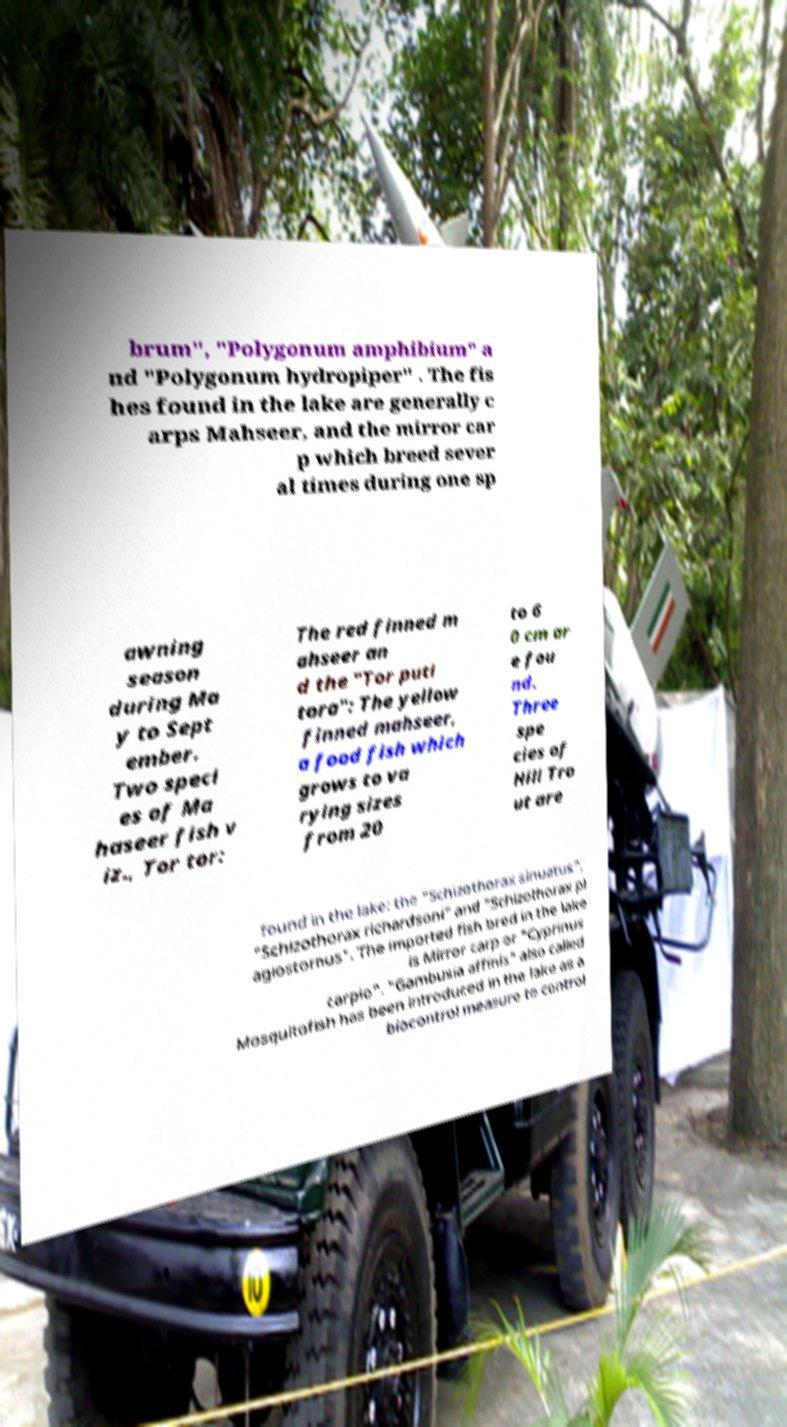Can you accurately transcribe the text from the provided image for me? brum", "Polygonum amphibium" a nd "Polygonum hydropiper" . The fis hes found in the lake are generally c arps Mahseer, and the mirror car p which breed sever al times during one sp awning season during Ma y to Sept ember. Two speci es of Ma haseer fish v iz., Tor tor: The red finned m ahseer an d the "Tor puti tora": The yellow finned mahseer, a food fish which grows to va rying sizes from 20 to 6 0 cm ar e fou nd. Three spe cies of Hill Tro ut are found in the lake: the "Schizothorax sinuatus", "Schizothorax richardsoni" and "Schizothorax pl agiostornus". The imported fish bred in the lake is Mirror carp or "Cyprinus carpio". "Gambusia affinis" also called Mosquitofish has been introduced in the lake as a biocontrol measure to control 